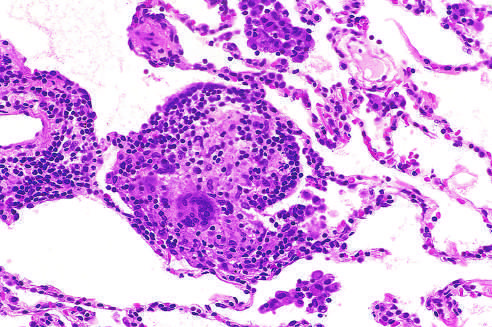re loosely formed interstitial granulomas and chronic inflammation characteristic?
Answer the question using a single word or phrase. Yes 